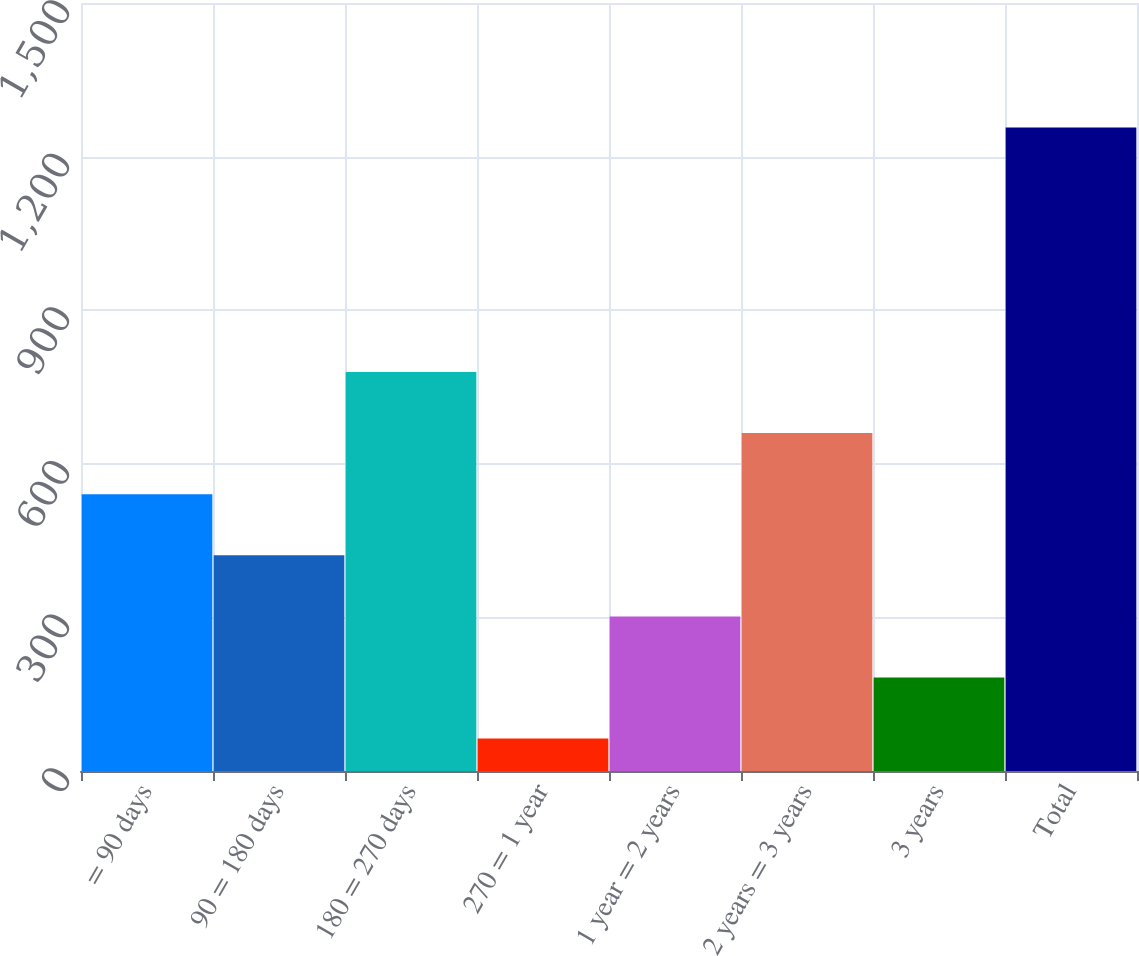<chart> <loc_0><loc_0><loc_500><loc_500><bar_chart><fcel>= 90 days<fcel>90 = 180 days<fcel>180 = 270 days<fcel>270 = 1 year<fcel>1 year = 2 years<fcel>2 years = 3 years<fcel>3 years<fcel>Total<nl><fcel>540.7<fcel>421.35<fcel>779.4<fcel>63.3<fcel>302<fcel>660.05<fcel>182.65<fcel>1256.8<nl></chart> 